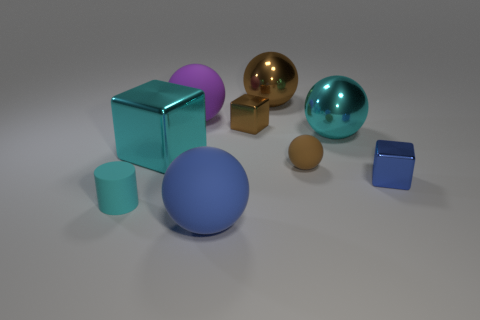Can you tell which object is the largest and which one is the smallest in this scene? Certainly, in this scene, the largest object is the teal-colored cube on the left, while the smallest item is the tiny brown sphere located towards the front, near the golden-yellow cube. 